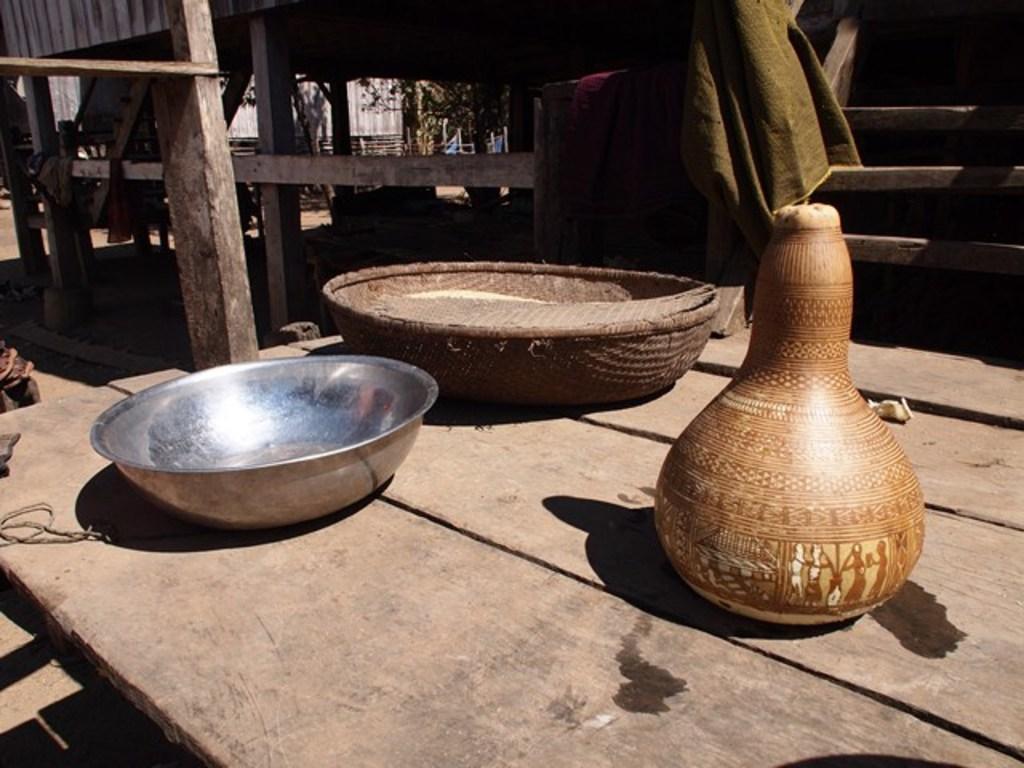Describe this image in one or two sentences. In this picture we can see a bowl, basket and a jar on the table, in the background we can see few trees and wooden barks. 